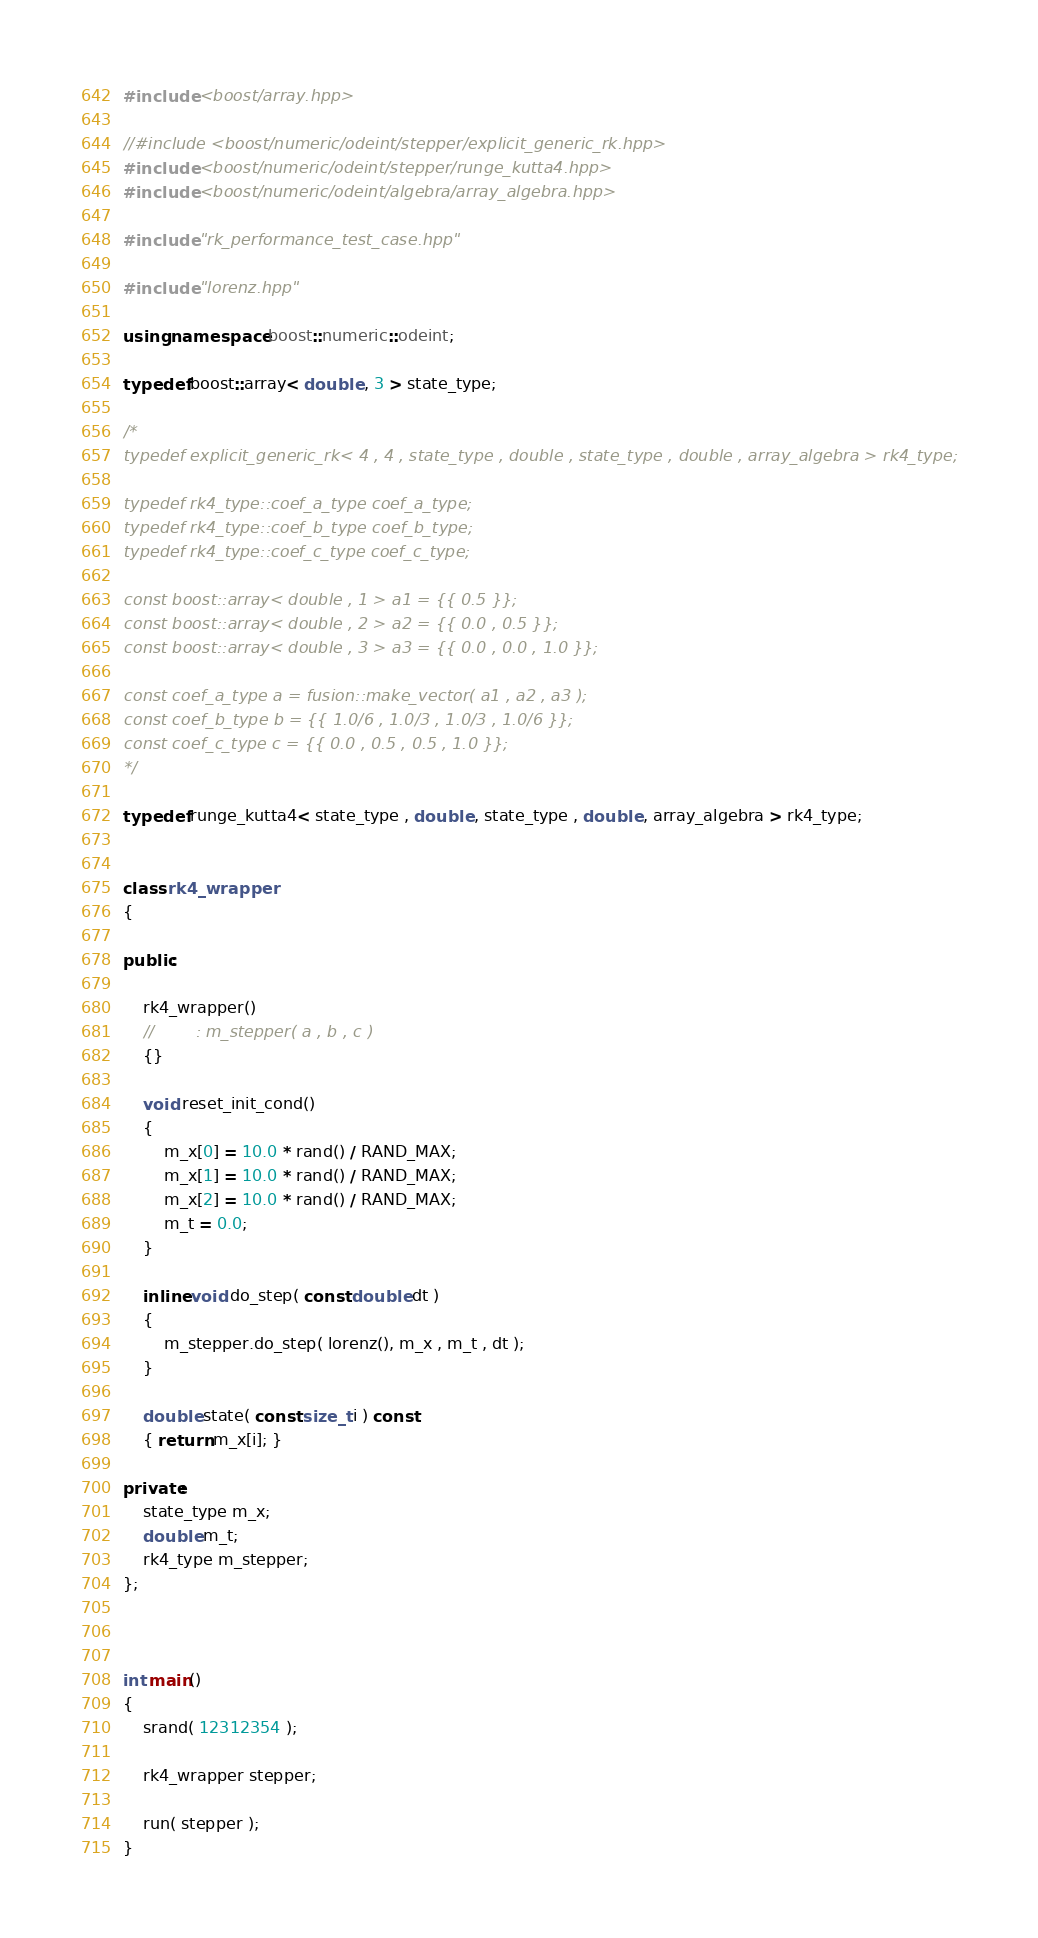Convert code to text. <code><loc_0><loc_0><loc_500><loc_500><_C++_>

#include <boost/array.hpp>

//#include <boost/numeric/odeint/stepper/explicit_generic_rk.hpp>
#include <boost/numeric/odeint/stepper/runge_kutta4.hpp>
#include <boost/numeric/odeint/algebra/array_algebra.hpp>

#include "rk_performance_test_case.hpp"

#include "lorenz.hpp"

using namespace boost::numeric::odeint;

typedef boost::array< double , 3 > state_type;

/*
typedef explicit_generic_rk< 4 , 4 , state_type , double , state_type , double , array_algebra > rk4_type;

typedef rk4_type::coef_a_type coef_a_type;
typedef rk4_type::coef_b_type coef_b_type;
typedef rk4_type::coef_c_type coef_c_type;

const boost::array< double , 1 > a1 = {{ 0.5 }};
const boost::array< double , 2 > a2 = {{ 0.0 , 0.5 }};
const boost::array< double , 3 > a3 = {{ 0.0 , 0.0 , 1.0 }};

const coef_a_type a = fusion::make_vector( a1 , a2 , a3 );
const coef_b_type b = {{ 1.0/6 , 1.0/3 , 1.0/3 , 1.0/6 }};
const coef_c_type c = {{ 0.0 , 0.5 , 0.5 , 1.0 }};
*/

typedef runge_kutta4< state_type , double , state_type , double , array_algebra > rk4_type;


class rk4_wrapper
{

public:

    rk4_wrapper()
    //        : m_stepper( a , b , c ) 
    {}

    void reset_init_cond()
    {
        m_x[0] = 10.0 * rand() / RAND_MAX;
        m_x[1] = 10.0 * rand() / RAND_MAX;
        m_x[2] = 10.0 * rand() / RAND_MAX;
        m_t = 0.0;
    }

    inline void do_step( const double dt )
    {
        m_stepper.do_step( lorenz(), m_x , m_t , dt );
    }

    double state( const size_t i ) const
    { return m_x[i]; }

private:
    state_type m_x;
    double m_t;
    rk4_type m_stepper;
};



int main()
{
    srand( 12312354 );

    rk4_wrapper stepper;

    run( stepper );
}
</code> 